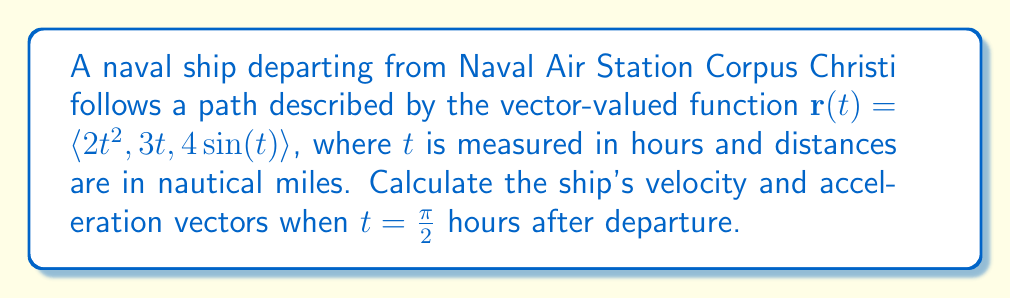Provide a solution to this math problem. To solve this problem, we need to find the velocity and acceleration vectors by differentiating the position vector $\mathbf{r}(t)$.

1. Velocity vector:
The velocity vector is the first derivative of the position vector with respect to time.

$$\mathbf{v}(t) = \frac{d\mathbf{r}}{dt} = \left\langle \frac{d}{dt}(2t^2), \frac{d}{dt}(3t), \frac{d}{dt}(4\sin(t)) \right\rangle$$

$$\mathbf{v}(t) = \langle 4t, 3, 4\cos(t) \rangle$$

2. Acceleration vector:
The acceleration vector is the second derivative of the position vector, or the first derivative of the velocity vector.

$$\mathbf{a}(t) = \frac{d\mathbf{v}}{dt} = \left\langle \frac{d}{dt}(4t), \frac{d}{dt}(3), \frac{d}{dt}(4\cos(t)) \right\rangle$$

$$\mathbf{a}(t) = \langle 4, 0, -4\sin(t) \rangle$$

3. Evaluate at $t = \frac{\pi}{2}$:

Velocity:
$$\mathbf{v}\left(\frac{\pi}{2}\right) = \left\langle 4\left(\frac{\pi}{2}\right), 3, 4\cos\left(\frac{\pi}{2}\right) \right\rangle = \langle 2\pi, 3, 0 \rangle$$

Acceleration:
$$\mathbf{a}\left(\frac{\pi}{2}\right) = \left\langle 4, 0, -4\sin\left(\frac{\pi}{2}\right) \right\rangle = \langle 4, 0, -4 \rangle$$
Answer: Velocity vector: $\mathbf{v}\left(\frac{\pi}{2}\right) = \langle 2\pi, 3, 0 \rangle$ nautical miles per hour
Acceleration vector: $\mathbf{a}\left(\frac{\pi}{2}\right) = \langle 4, 0, -4 \rangle$ nautical miles per hour squared 